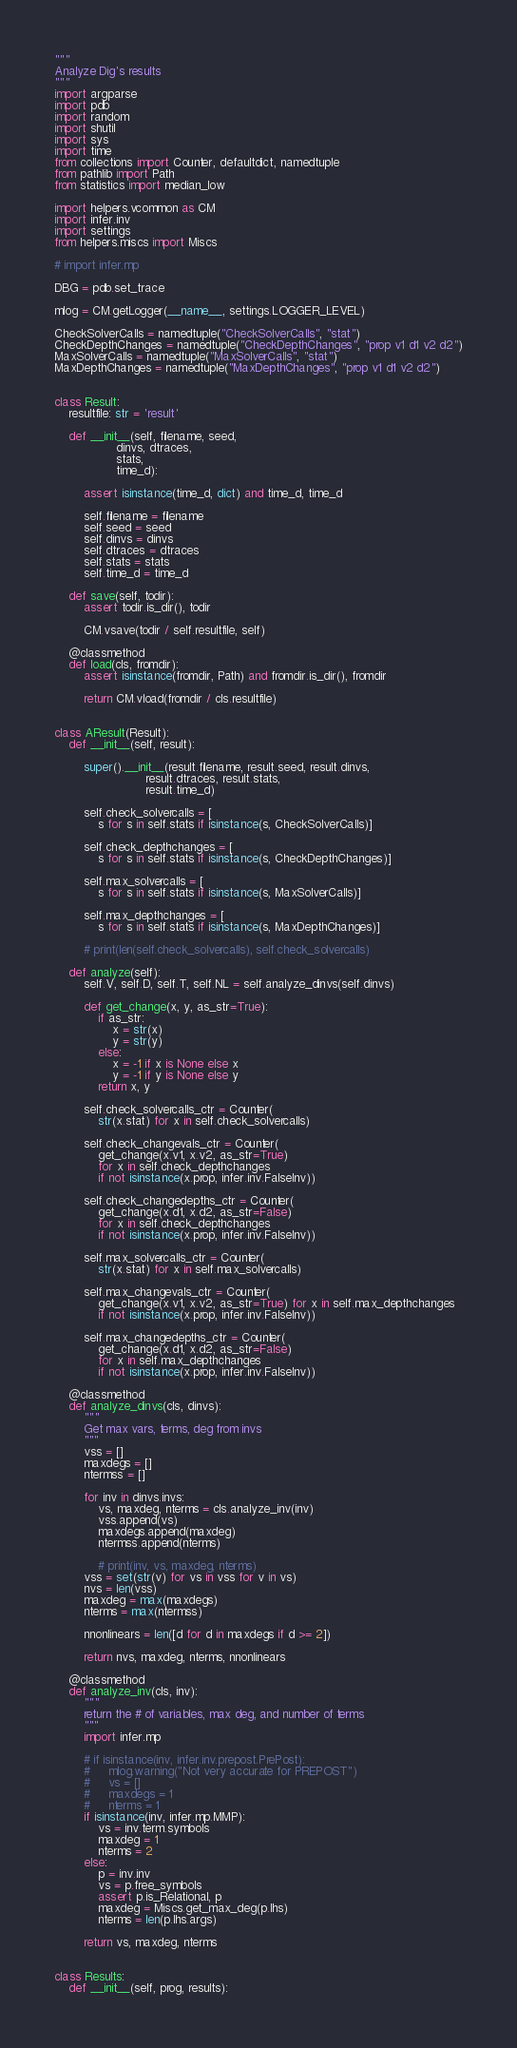Convert code to text. <code><loc_0><loc_0><loc_500><loc_500><_Python_>"""
Analyze Dig's results
"""
import argparse
import pdb
import random
import shutil
import sys
import time
from collections import Counter, defaultdict, namedtuple
from pathlib import Path
from statistics import median_low

import helpers.vcommon as CM
import infer.inv
import settings
from helpers.miscs import Miscs

# import infer.mp

DBG = pdb.set_trace

mlog = CM.getLogger(__name__, settings.LOGGER_LEVEL)

CheckSolverCalls = namedtuple("CheckSolverCalls", "stat")
CheckDepthChanges = namedtuple("CheckDepthChanges", "prop v1 d1 v2 d2")
MaxSolverCalls = namedtuple("MaxSolverCalls", "stat")
MaxDepthChanges = namedtuple("MaxDepthChanges", "prop v1 d1 v2 d2")


class Result:
    resultfile: str = 'result'

    def __init__(self, filename, seed,
                 dinvs, dtraces,
                 stats,
                 time_d):

        assert isinstance(time_d, dict) and time_d, time_d

        self.filename = filename
        self.seed = seed
        self.dinvs = dinvs
        self.dtraces = dtraces
        self.stats = stats
        self.time_d = time_d

    def save(self, todir):
        assert todir.is_dir(), todir

        CM.vsave(todir / self.resultfile, self)

    @classmethod
    def load(cls, fromdir):
        assert isinstance(fromdir, Path) and fromdir.is_dir(), fromdir

        return CM.vload(fromdir / cls.resultfile)


class AResult(Result):
    def __init__(self, result):

        super().__init__(result.filename, result.seed, result.dinvs,
                         result.dtraces, result.stats,
                         result.time_d)

        self.check_solvercalls = [
            s for s in self.stats if isinstance(s, CheckSolverCalls)]

        self.check_depthchanges = [
            s for s in self.stats if isinstance(s, CheckDepthChanges)]

        self.max_solvercalls = [
            s for s in self.stats if isinstance(s, MaxSolverCalls)]

        self.max_depthchanges = [
            s for s in self.stats if isinstance(s, MaxDepthChanges)]

        # print(len(self.check_solvercalls), self.check_solvercalls)

    def analyze(self):
        self.V, self.D, self.T, self.NL = self.analyze_dinvs(self.dinvs)

        def get_change(x, y, as_str=True):
            if as_str:
                x = str(x)
                y = str(y)
            else:
                x = -1 if x is None else x
                y = -1 if y is None else y
            return x, y

        self.check_solvercalls_ctr = Counter(
            str(x.stat) for x in self.check_solvercalls)

        self.check_changevals_ctr = Counter(
            get_change(x.v1, x.v2, as_str=True)
            for x in self.check_depthchanges
            if not isinstance(x.prop, infer.inv.FalseInv))

        self.check_changedepths_ctr = Counter(
            get_change(x.d1, x.d2, as_str=False)
            for x in self.check_depthchanges
            if not isinstance(x.prop, infer.inv.FalseInv))

        self.max_solvercalls_ctr = Counter(
            str(x.stat) for x in self.max_solvercalls)

        self.max_changevals_ctr = Counter(
            get_change(x.v1, x.v2, as_str=True) for x in self.max_depthchanges
            if not isinstance(x.prop, infer.inv.FalseInv))

        self.max_changedepths_ctr = Counter(
            get_change(x.d1, x.d2, as_str=False)
            for x in self.max_depthchanges
            if not isinstance(x.prop, infer.inv.FalseInv))

    @classmethod
    def analyze_dinvs(cls, dinvs):
        """
        Get max vars, terms, deg from invs
        """
        vss = []
        maxdegs = []
        ntermss = []

        for inv in dinvs.invs:
            vs, maxdeg, nterms = cls.analyze_inv(inv)
            vss.append(vs)
            maxdegs.append(maxdeg)
            ntermss.append(nterms)

            # print(inv, vs, maxdeg, nterms)
        vss = set(str(v) for vs in vss for v in vs)
        nvs = len(vss)
        maxdeg = max(maxdegs)
        nterms = max(ntermss)

        nnonlinears = len([d for d in maxdegs if d >= 2])

        return nvs, maxdeg, nterms, nnonlinears

    @classmethod
    def analyze_inv(cls, inv):
        """
        return the # of variables, max deg, and number of terms
        """
        import infer.mp

        # if isinstance(inv, infer.inv.prepost.PrePost):
        #     mlog.warning("Not very accurate for PREPOST")
        #     vs = []
        #     maxdegs = 1
        #     nterms = 1
        if isinstance(inv, infer.mp.MMP):
            vs = inv.term.symbols
            maxdeg = 1
            nterms = 2
        else:
            p = inv.inv
            vs = p.free_symbols
            assert p.is_Relational, p
            maxdeg = Miscs.get_max_deg(p.lhs)
            nterms = len(p.lhs.args)

        return vs, maxdeg, nterms


class Results:
    def __init__(self, prog, results):</code> 